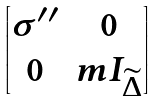<formula> <loc_0><loc_0><loc_500><loc_500>\begin{bmatrix} \sigma ^ { \prime \prime } & 0 \\ 0 & m I _ { \widetilde { \Delta } } \end{bmatrix}</formula> 